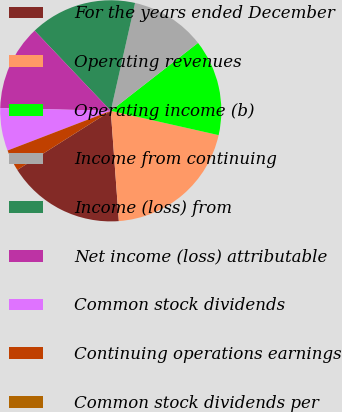Convert chart to OTSL. <chart><loc_0><loc_0><loc_500><loc_500><pie_chart><fcel>For the years ended December<fcel>Operating revenues<fcel>Operating income (b)<fcel>Income from continuing<fcel>Income (loss) from<fcel>Net income (loss) attributable<fcel>Common stock dividends<fcel>Continuing operations earnings<fcel>Common stock dividends per<nl><fcel>17.19%<fcel>20.31%<fcel>14.06%<fcel>10.94%<fcel>15.62%<fcel>12.5%<fcel>6.25%<fcel>3.13%<fcel>0.0%<nl></chart> 